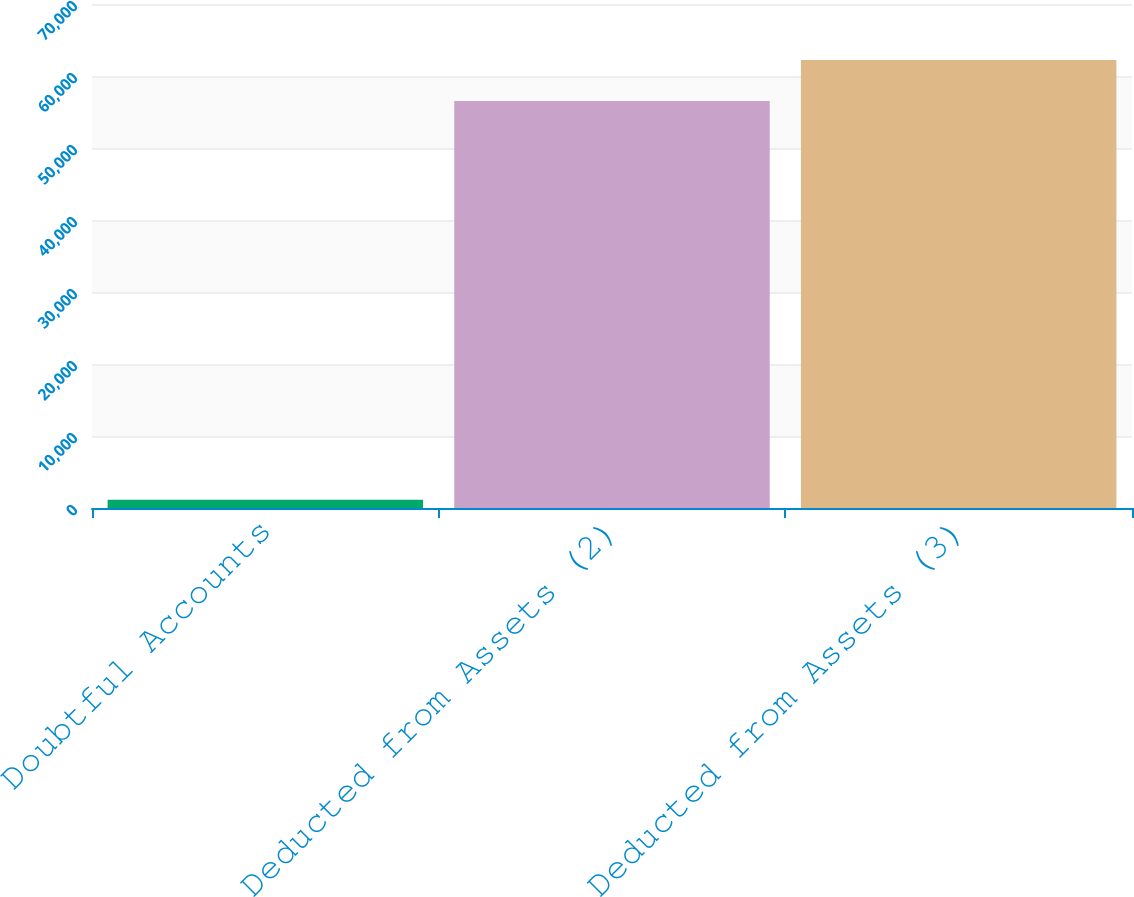<chart> <loc_0><loc_0><loc_500><loc_500><bar_chart><fcel>Doubtful Accounts<fcel>Deducted from Assets (2)<fcel>Deducted from Assets (3)<nl><fcel>1130<fcel>56530<fcel>62235.7<nl></chart> 